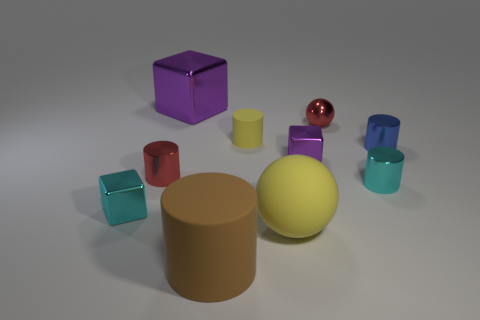What emotions or concepts might this collection of objects represent? The assortment of shapes and colors could evoke notions of diversity and variety, symbolizing the beauty of distinct individuality coming together in a cohesive and orderly fashion. 